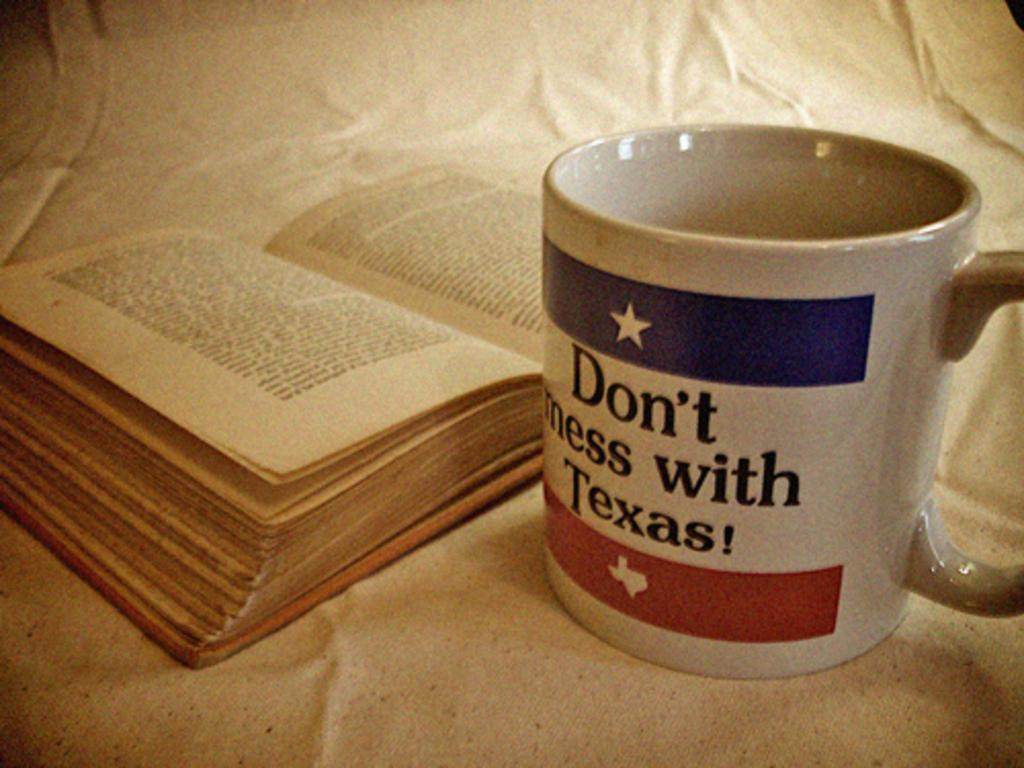Provide a one-sentence caption for the provided image. A book next to a mug saying Don't mess with Texas. 